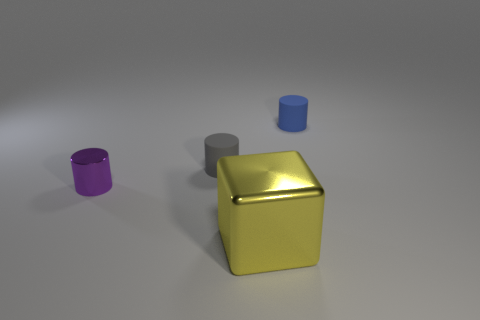Subtract all red blocks. Subtract all yellow cylinders. How many blocks are left? 1 Add 4 big yellow metal objects. How many objects exist? 8 Subtract all cubes. How many objects are left? 3 Add 3 tiny red matte cylinders. How many tiny red matte cylinders exist? 3 Subtract 0 blue spheres. How many objects are left? 4 Subtract all yellow metallic things. Subtract all yellow metal cubes. How many objects are left? 2 Add 2 big yellow shiny things. How many big yellow shiny things are left? 3 